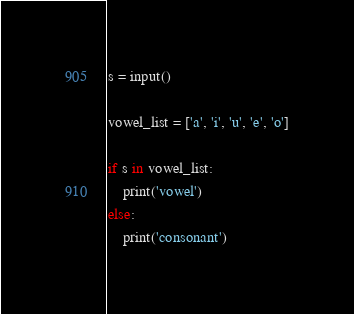Convert code to text. <code><loc_0><loc_0><loc_500><loc_500><_Python_>s = input()

vowel_list = ['a', 'i', 'u', 'e', 'o']

if s in vowel_list:
    print('vowel')
else:
    print('consonant')
</code> 